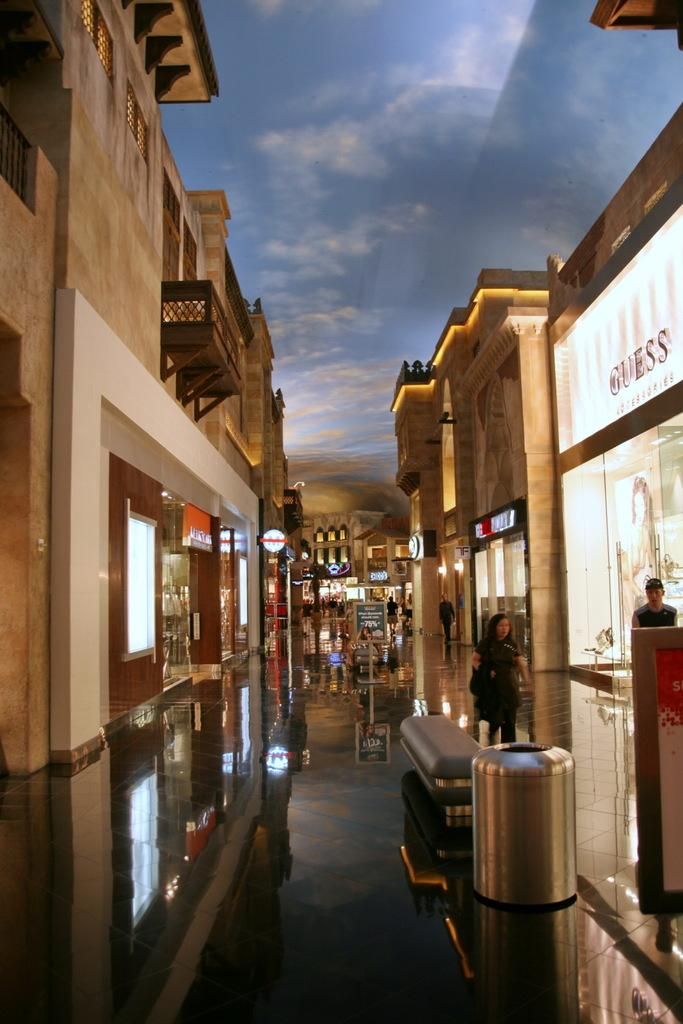What type of establishments can be seen in the image? There are stores in the image. What is the lady in the image doing? A lady is walking on the footpath in the image. How is the man positioned in relation to the stores? A man is standing near a store in the image. What type of goose can be seen interacting with the man near the store? There is no goose present in the image; it only features a lady walking on the footpath and a man standing near a store. What advice might the lady's father give her in the image? There is no mention of the lady's father in the image, so it is impossible to determine what advice he might give. 